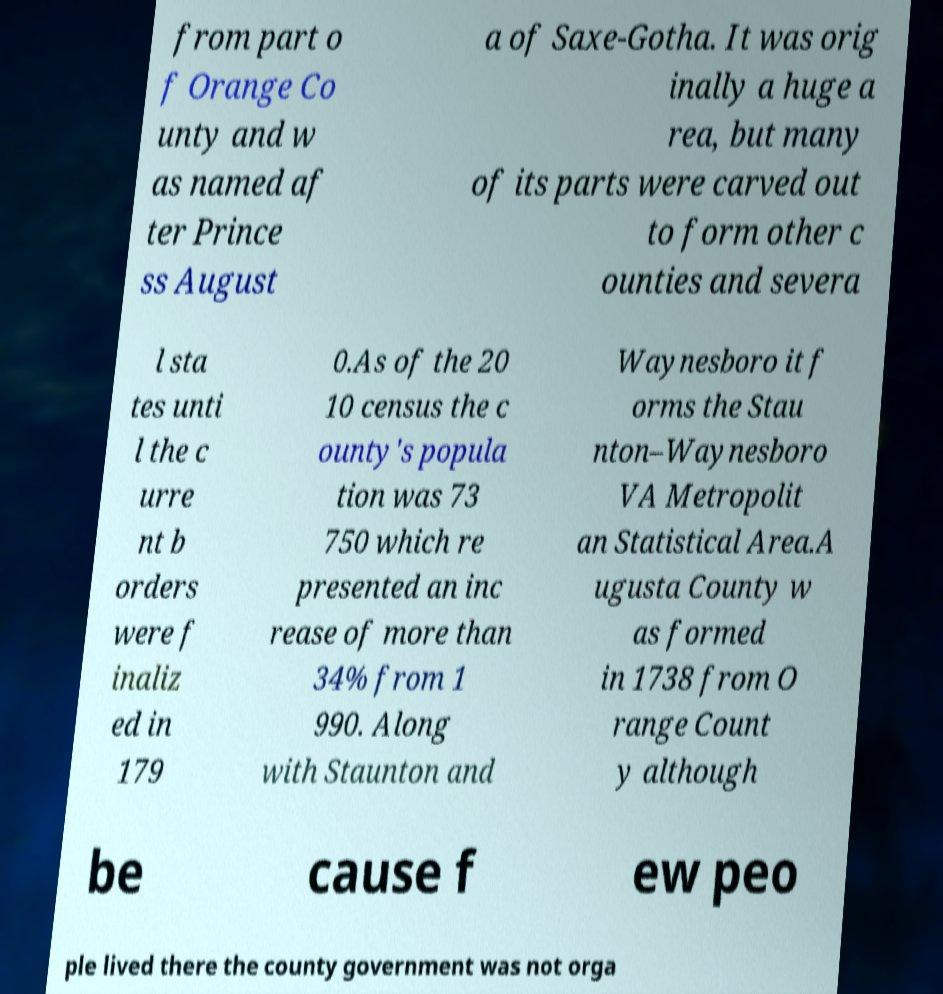I need the written content from this picture converted into text. Can you do that? from part o f Orange Co unty and w as named af ter Prince ss August a of Saxe-Gotha. It was orig inally a huge a rea, but many of its parts were carved out to form other c ounties and severa l sta tes unti l the c urre nt b orders were f inaliz ed in 179 0.As of the 20 10 census the c ounty's popula tion was 73 750 which re presented an inc rease of more than 34% from 1 990. Along with Staunton and Waynesboro it f orms the Stau nton–Waynesboro VA Metropolit an Statistical Area.A ugusta County w as formed in 1738 from O range Count y although be cause f ew peo ple lived there the county government was not orga 